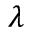Convert formula to latex. <formula><loc_0><loc_0><loc_500><loc_500>\lambda</formula> 